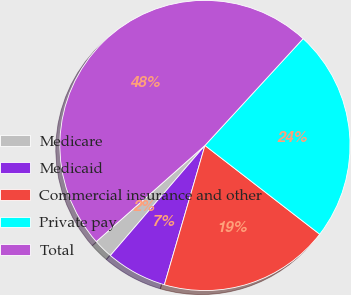Convert chart to OTSL. <chart><loc_0><loc_0><loc_500><loc_500><pie_chart><fcel>Medicare<fcel>Medicaid<fcel>Commercial insurance and other<fcel>Private pay<fcel>Total<nl><fcel>2.17%<fcel>6.79%<fcel>19.03%<fcel>23.65%<fcel>48.36%<nl></chart> 